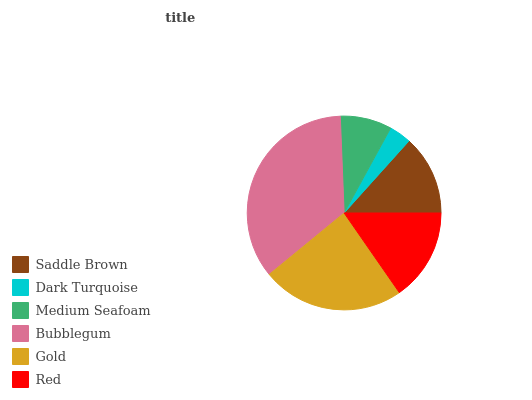Is Dark Turquoise the minimum?
Answer yes or no. Yes. Is Bubblegum the maximum?
Answer yes or no. Yes. Is Medium Seafoam the minimum?
Answer yes or no. No. Is Medium Seafoam the maximum?
Answer yes or no. No. Is Medium Seafoam greater than Dark Turquoise?
Answer yes or no. Yes. Is Dark Turquoise less than Medium Seafoam?
Answer yes or no. Yes. Is Dark Turquoise greater than Medium Seafoam?
Answer yes or no. No. Is Medium Seafoam less than Dark Turquoise?
Answer yes or no. No. Is Red the high median?
Answer yes or no. Yes. Is Saddle Brown the low median?
Answer yes or no. Yes. Is Dark Turquoise the high median?
Answer yes or no. No. Is Gold the low median?
Answer yes or no. No. 